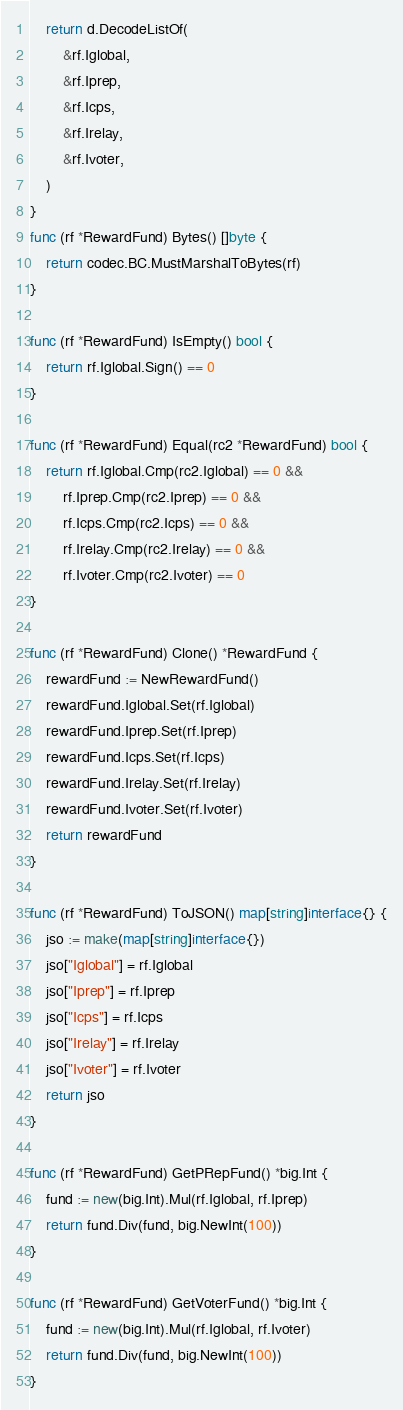<code> <loc_0><loc_0><loc_500><loc_500><_Go_>	return d.DecodeListOf(
		&rf.Iglobal,
		&rf.Iprep,
		&rf.Icps,
		&rf.Irelay,
		&rf.Ivoter,
	)
}
func (rf *RewardFund) Bytes() []byte {
	return codec.BC.MustMarshalToBytes(rf)
}

func (rf *RewardFund) IsEmpty() bool {
	return rf.Iglobal.Sign() == 0
}

func (rf *RewardFund) Equal(rc2 *RewardFund) bool {
	return rf.Iglobal.Cmp(rc2.Iglobal) == 0 &&
		rf.Iprep.Cmp(rc2.Iprep) == 0 &&
		rf.Icps.Cmp(rc2.Icps) == 0 &&
		rf.Irelay.Cmp(rc2.Irelay) == 0 &&
		rf.Ivoter.Cmp(rc2.Ivoter) == 0
}

func (rf *RewardFund) Clone() *RewardFund {
	rewardFund := NewRewardFund()
	rewardFund.Iglobal.Set(rf.Iglobal)
	rewardFund.Iprep.Set(rf.Iprep)
	rewardFund.Icps.Set(rf.Icps)
	rewardFund.Irelay.Set(rf.Irelay)
	rewardFund.Ivoter.Set(rf.Ivoter)
	return rewardFund
}

func (rf *RewardFund) ToJSON() map[string]interface{} {
	jso := make(map[string]interface{})
	jso["Iglobal"] = rf.Iglobal
	jso["Iprep"] = rf.Iprep
	jso["Icps"] = rf.Icps
	jso["Irelay"] = rf.Irelay
	jso["Ivoter"] = rf.Ivoter
	return jso
}

func (rf *RewardFund) GetPRepFund() *big.Int {
	fund := new(big.Int).Mul(rf.Iglobal, rf.Iprep)
	return fund.Div(fund, big.NewInt(100))
}

func (rf *RewardFund) GetVoterFund() *big.Int {
	fund := new(big.Int).Mul(rf.Iglobal, rf.Ivoter)
	return fund.Div(fund, big.NewInt(100))
}
</code> 